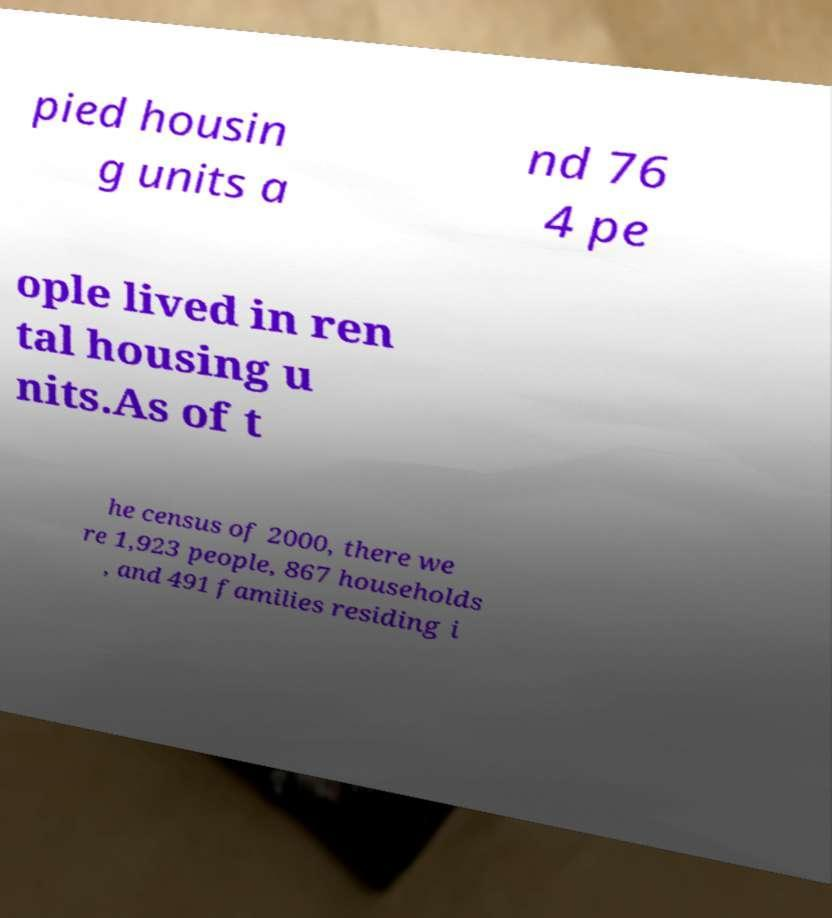For documentation purposes, I need the text within this image transcribed. Could you provide that? pied housin g units a nd 76 4 pe ople lived in ren tal housing u nits.As of t he census of 2000, there we re 1,923 people, 867 households , and 491 families residing i 